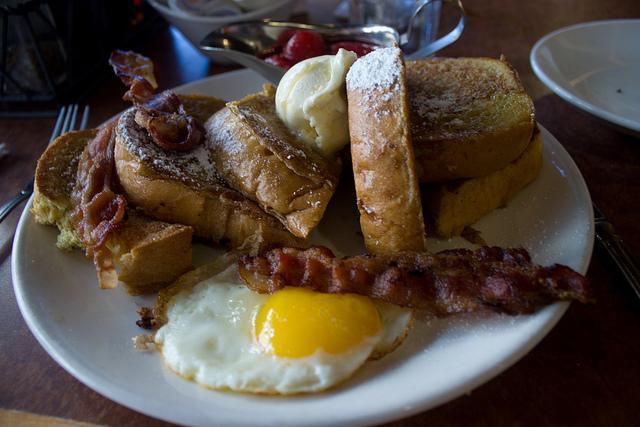How many pieces of ham are on the plate?
Give a very brief answer. 0. How many fried eggs can be seen?
Give a very brief answer. 1. How many bowls are there?
Give a very brief answer. 3. How many sandwiches are there?
Give a very brief answer. 3. How many people can be seen easily in this picture?
Give a very brief answer. 0. 